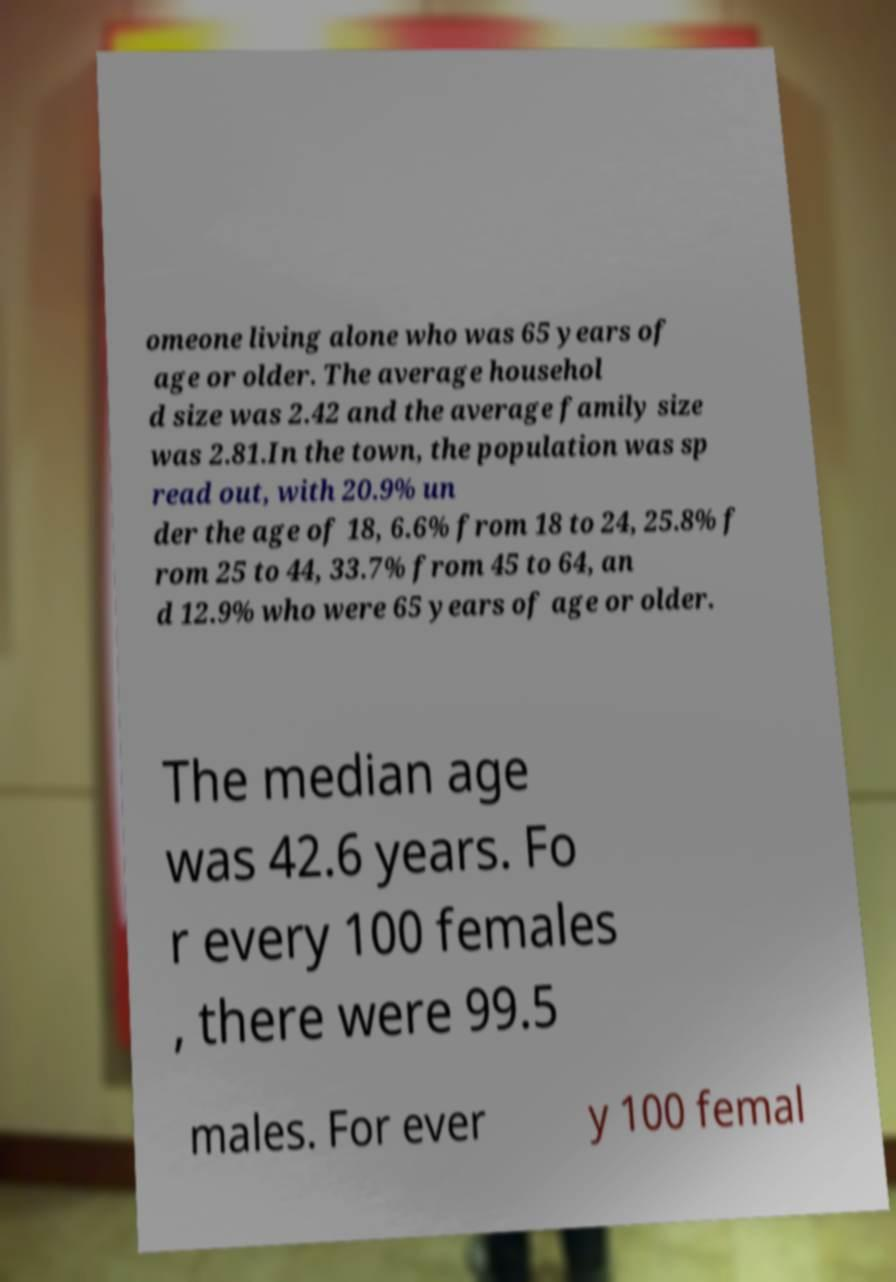Please read and relay the text visible in this image. What does it say? omeone living alone who was 65 years of age or older. The average househol d size was 2.42 and the average family size was 2.81.In the town, the population was sp read out, with 20.9% un der the age of 18, 6.6% from 18 to 24, 25.8% f rom 25 to 44, 33.7% from 45 to 64, an d 12.9% who were 65 years of age or older. The median age was 42.6 years. Fo r every 100 females , there were 99.5 males. For ever y 100 femal 